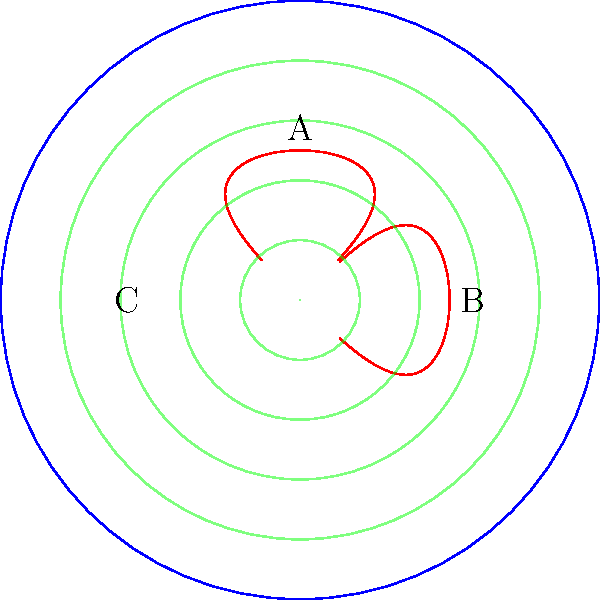In the hyperbolic space represented by the Poincaré disk model above, sound waves are visualized as concentric circles. If a sound source is placed at point A, how would the acoustic design of your venue differ compared to Euclidean space, particularly regarding the paths between points B and C? To understand the acoustic design implications in hyperbolic space, we need to consider the following steps:

1. In the Poincaré disk model, straight lines in hyperbolic space are represented by arcs that intersect the boundary circle perpendicularly.

2. The red curves in the diagram represent geodesics (shortest paths) in hyperbolic space.

3. In Euclidean space, sound waves spread out in straight lines, and the distance between points B and C would be a straight line.

4. In hyperbolic space, the shortest path between B and C is along the curved geodesic, which is longer than it appears in the Euclidean sense.

5. Sound waves in hyperbolic space, represented by the green circles, spread out more rapidly than in Euclidean space. This is because the area of a circle in hyperbolic space grows exponentially with its radius, unlike in Euclidean space where it grows quadratically.

6. The rapid spreading of sound waves means that sound intensity decreases more quickly with distance in hyperbolic space.

7. The curved geodesics also imply that sound reflections would follow non-intuitive paths, potentially creating unique acoustic effects.

8. To optimize acoustic design in this hyperbolic venue, you would need to:
   a) Account for the faster decay of sound intensity with distance
   b) Consider the curved paths of sound reflections
   c) Potentially use the unique geometry to create interesting acoustic focal points

9. This could lead to a more intimate sound experience in some areas of the venue, while other areas might require additional sound reinforcement to compensate for the rapid intensity decrease.
Answer: Faster sound decay, curved reflection paths, unique focal points 